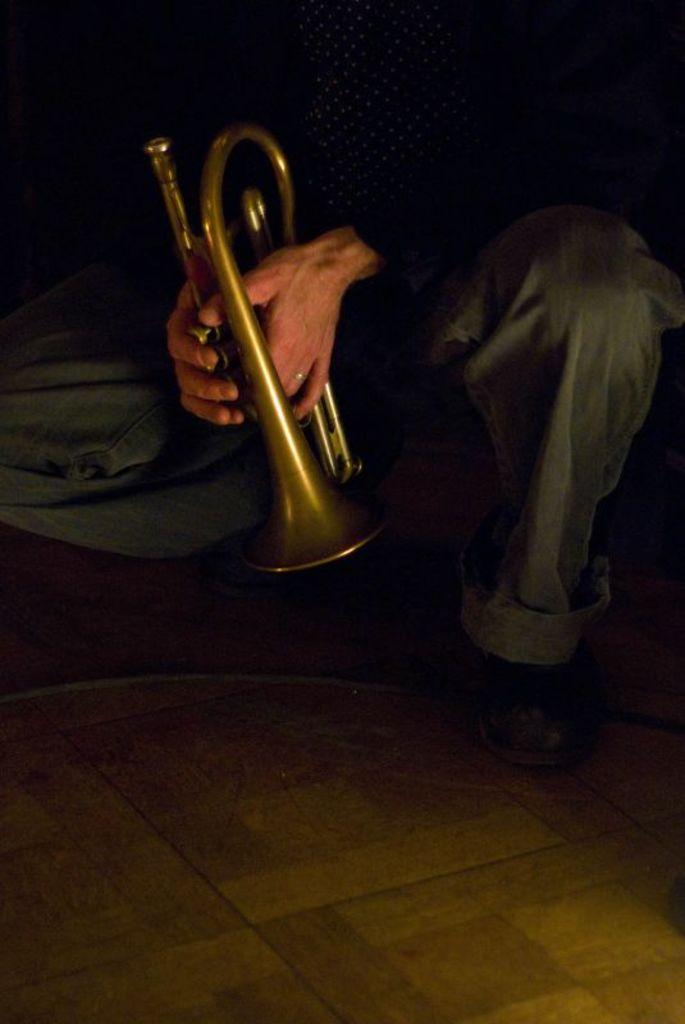What is the overall lighting condition of the image? The image is slightly dark. What instrument is being held by a person in the image? There is a person's hand holding a trumpet in the image. What part of the person's body can be seen in the image? The person's legs with shoes are visible in the image. What type of object can be seen in the image that is not related to the person or the trumpet? There is a wire in the image. What surface is the person standing on in the image? There is a floor in the image. What type of pen is being used to write letters on the floor in the image? There is no pen or letters being written on the floor in the image. 